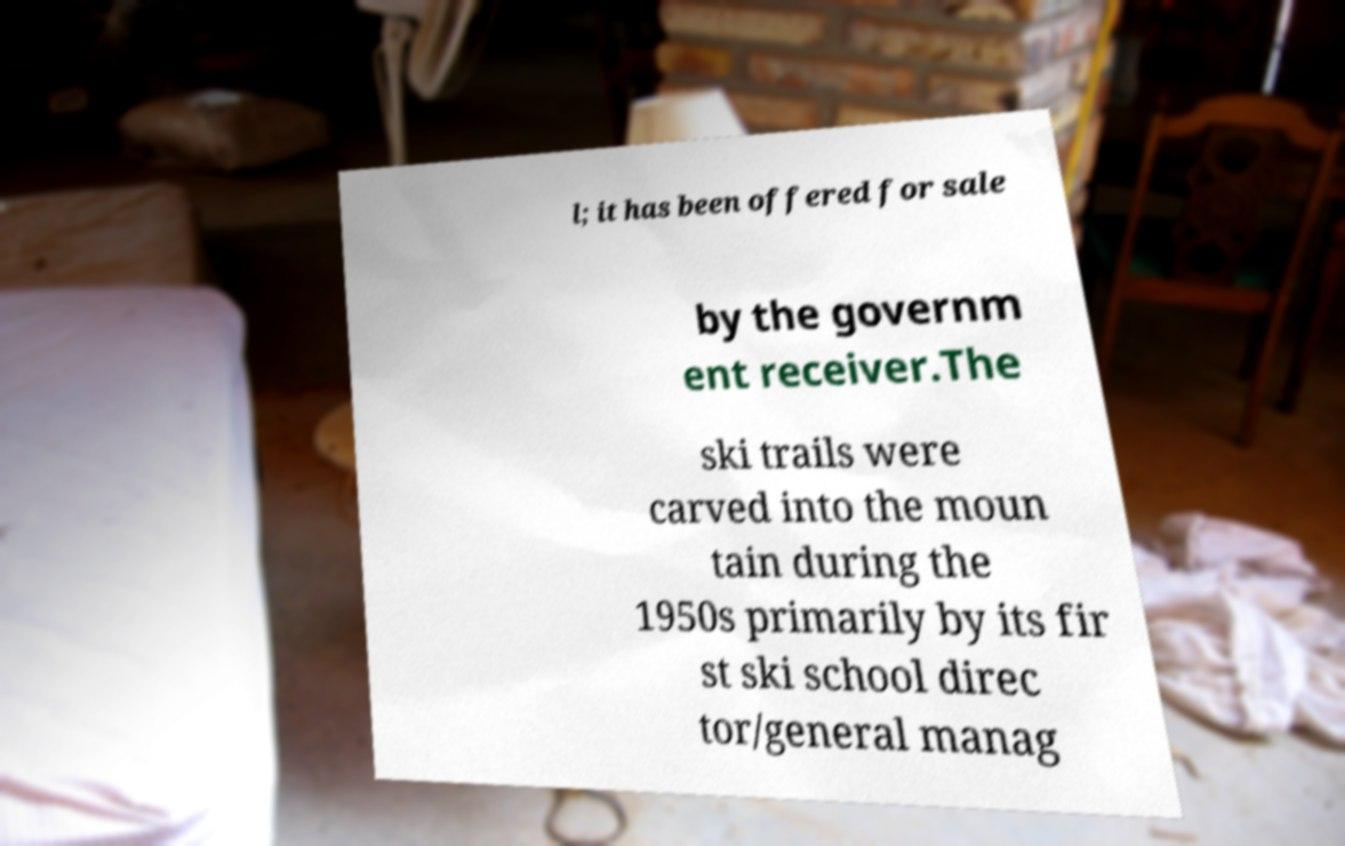Could you assist in decoding the text presented in this image and type it out clearly? l; it has been offered for sale by the governm ent receiver.The ski trails were carved into the moun tain during the 1950s primarily by its fir st ski school direc tor/general manag 